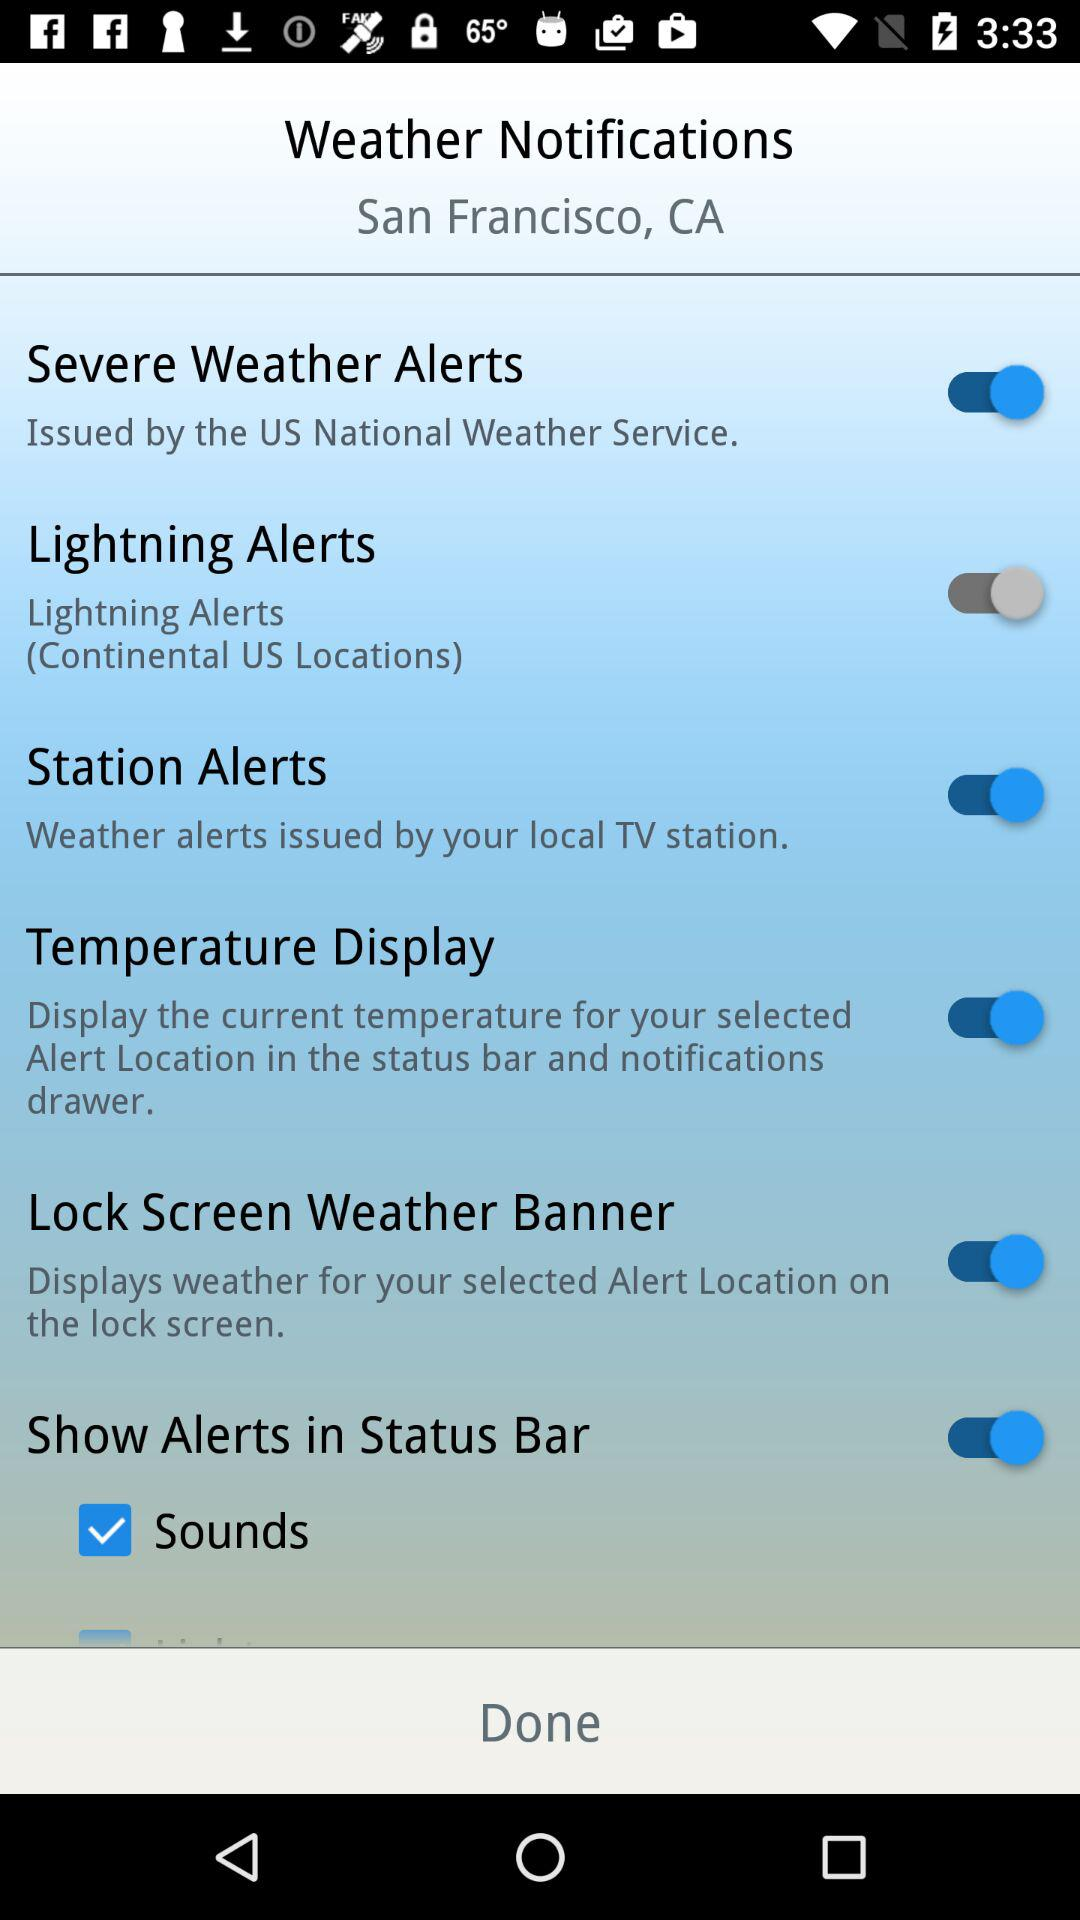Which options are enabled? The enabled options are "Severe Weather Alerts", "Station Alerts", "Temperature Display", "Lock Screen Weather Banner" and "Show Alerts in Status Bar". 